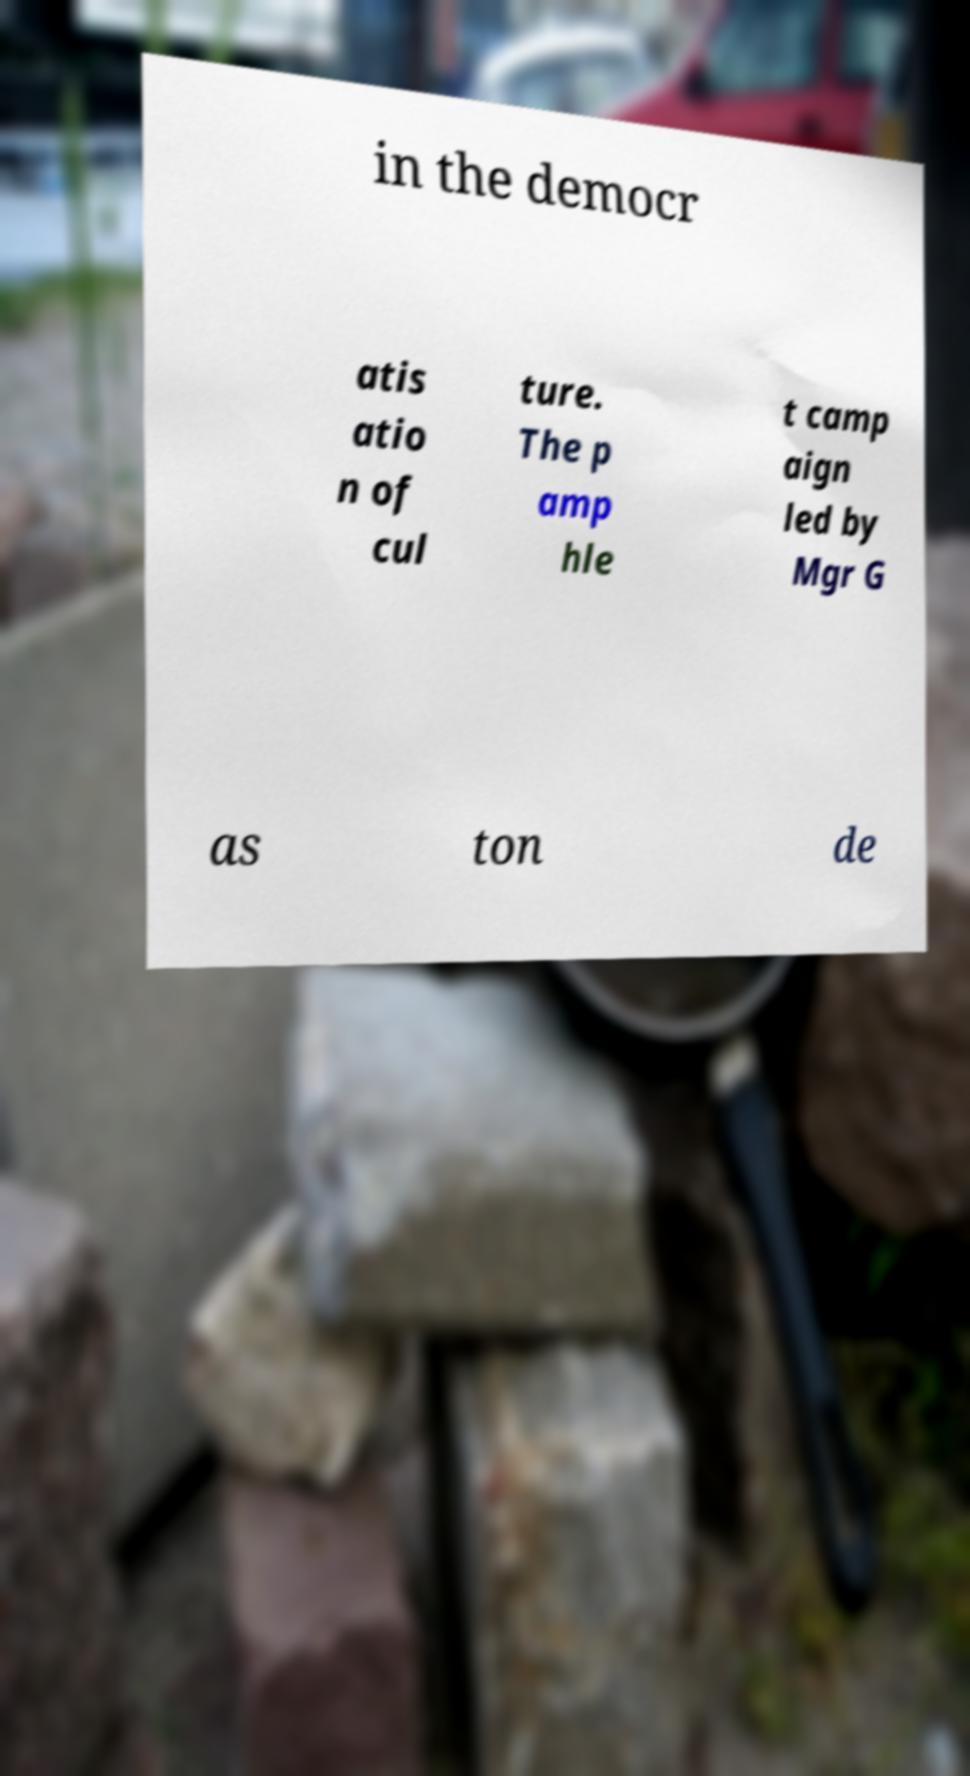I need the written content from this picture converted into text. Can you do that? in the democr atis atio n of cul ture. The p amp hle t camp aign led by Mgr G as ton de 